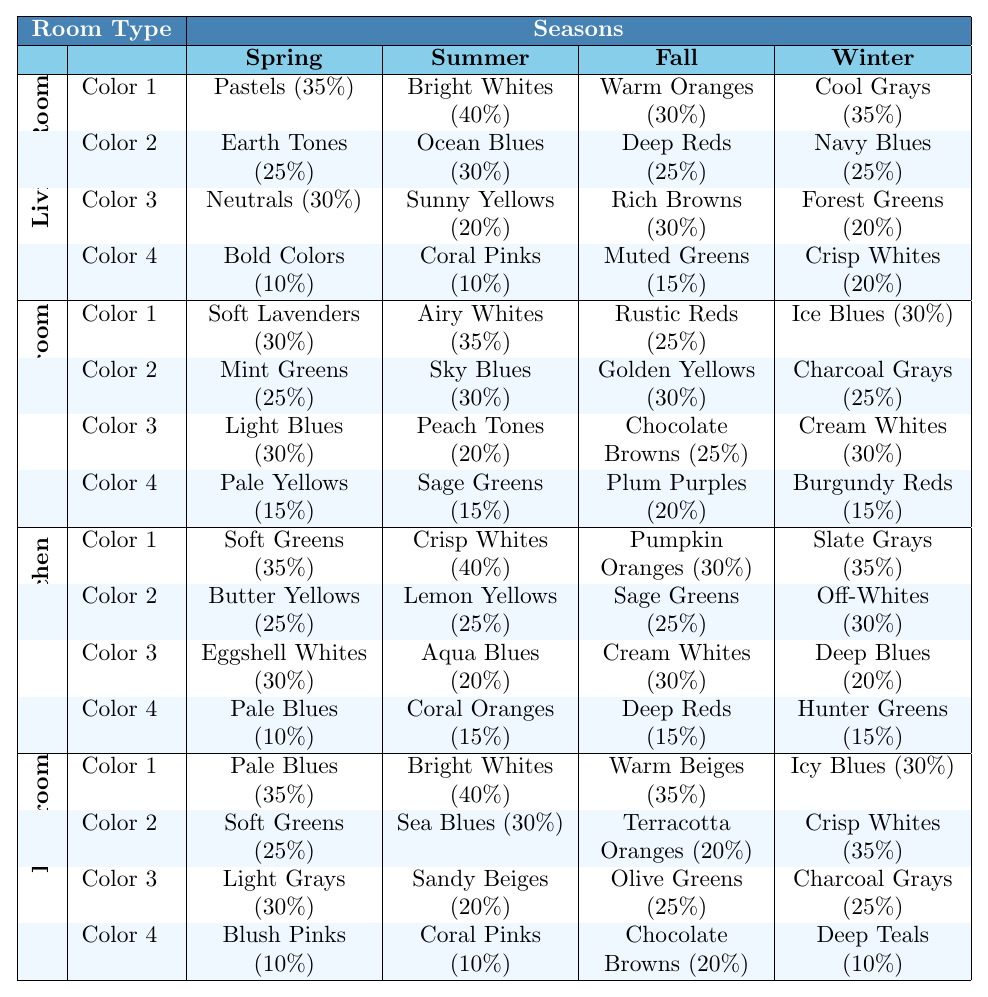What color is the most popular in the Living Room during Spring? In the Living Room during Spring, the most popular color is Pastels, with a percentage of 35%.
Answer: Pastels Which season has the highest percentage of Bright Whites in the Bathroom? The Bathroom has the highest percentage of Bright Whites during Summer, at 40%.
Answer: Summer What percentage of colors do not belong to the Earth Tones in the Living Room during Fall? In the Living Room during Fall, the colors are Warm Oranges (30%), Deep Reds (25%), Rich Browns (30%), and Muted Greens (15%). Earth Tones refers to Deep Reds, Rich Browns, and Muted Greens (25% + 30% + 15% = 70%). Thus, the percentage of colors not belonging to Earth Tones is 100% - 70% = 30%.
Answer: 30% What is the total percentage of Warm Beiges and Terracotta Oranges in the Bathroom during Fall? In the Bathroom during Fall, Warm Beiges are 35% and Terracotta Oranges are 20%. Adding these gives 35% + 20% = 55%.
Answer: 55% Which color is more popular in the Kitchen during Winter, Deep Blues or Hunter Greens? In the Kitchen during Winter, Deep Blues are at 20% while Hunter Greens are at 15%. Since 20% is greater than 15%, Deep Blues are more popular.
Answer: Deep Blues What is the most popular color in the Bedroom during Fall, and what percentage does it have relative to the other colors? In the Bedroom during Fall, Golden Yellows are the most popular at 30%. The other colors, Rustic Reds (25%), Chocolate Browns (25%), and Plum Purples (20%) bring the total to 100%. Thus, Golden Yellows represent 30% of the overall color trend for that season.
Answer: Golden Yellows (30%) What seasonal color trend in the Kitchen has both Eggshell Whites and Coral Oranges, and what is their combined percentage? The Kitchen's Spring season includes Eggshell Whites (30%) and Coral Oranges (15%). Their combined percentage is 30% + 15% = 45%.
Answer: 45% Is it true that the percentage of Soft Greens in the Bathroom during Spring is higher than the percentage of Light Grays in the Summer? In the Bathroom during Spring, Soft Greens are at 25%, while Light Grays in the Summer are at 30%. Since 25% is not higher than 30%, the statement is false.
Answer: False In which room and season would you most likely find the color Navy Blues, and how does it compare to Cool Grays? Navy Blues are found in the Living Room during Winter at 25%. Cool Grays in the same room and season have a higher percentage of 35% compared to Navy Blues.
Answer: Living Room, Winter; Cool Grays are more popular Calculate the difference in percentage between the most popular color in the Bedroom during Spring and the least popular color in the Kitchen during Summer. The most popular color in the Bedroom during Spring is Airy Whites at 35%, and the least popular in the Kitchen during Summer is Coral Oranges at 15%. The difference is 35% - 15% = 20%.
Answer: 20% 